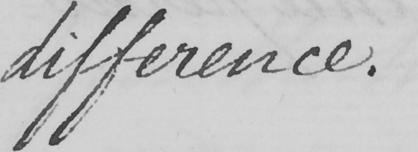What is written in this line of handwriting? difference . 